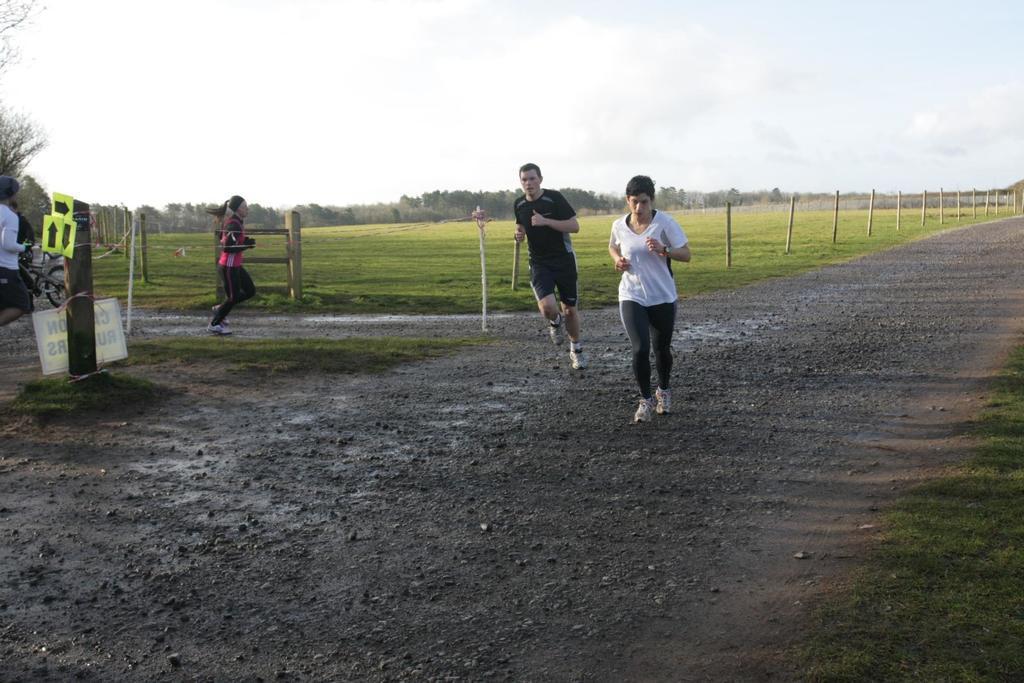Describe this image in one or two sentences. In this picture I can see few people running and a man walking and I can see another man holding bicycle and I can see trees and a board with some text and I can see grass on the ground and a cloudy sky. 